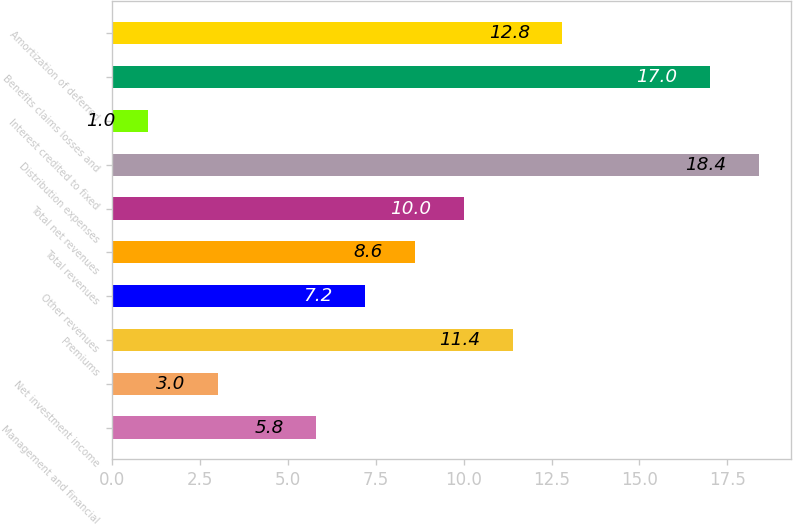Convert chart. <chart><loc_0><loc_0><loc_500><loc_500><bar_chart><fcel>Management and financial<fcel>Net investment income<fcel>Premiums<fcel>Other revenues<fcel>Total revenues<fcel>Total net revenues<fcel>Distribution expenses<fcel>Interest credited to fixed<fcel>Benefits claims losses and<fcel>Amortization of deferred<nl><fcel>5.8<fcel>3<fcel>11.4<fcel>7.2<fcel>8.6<fcel>10<fcel>18.4<fcel>1<fcel>17<fcel>12.8<nl></chart> 